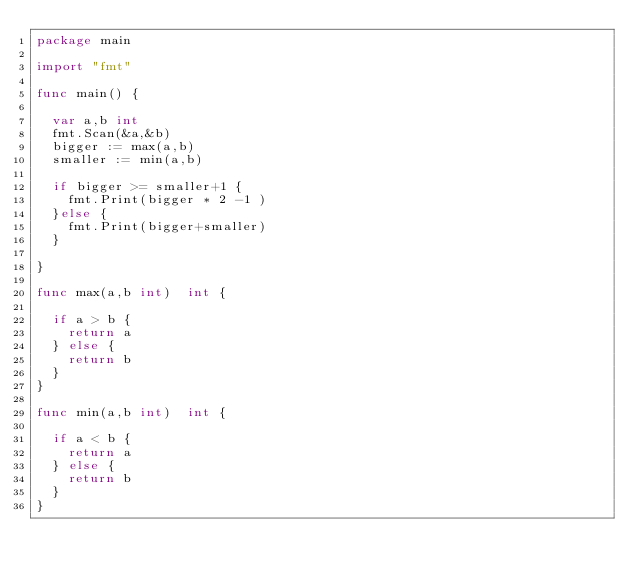Convert code to text. <code><loc_0><loc_0><loc_500><loc_500><_Go_>package main

import "fmt"

func main() {

  var a,b int
  fmt.Scan(&a,&b)
  bigger := max(a,b)
  smaller := min(a,b)
  
  if bigger >= smaller+1 {
    fmt.Print(bigger * 2 -1 )
  }else {
    fmt.Print(bigger+smaller)
  }
  
}

func max(a,b int)  int {

  if a > b {
    return a
  } else {
    return b
  }
}

func min(a,b int)  int {

  if a < b {
    return a
  } else {
    return b
  }
}
</code> 